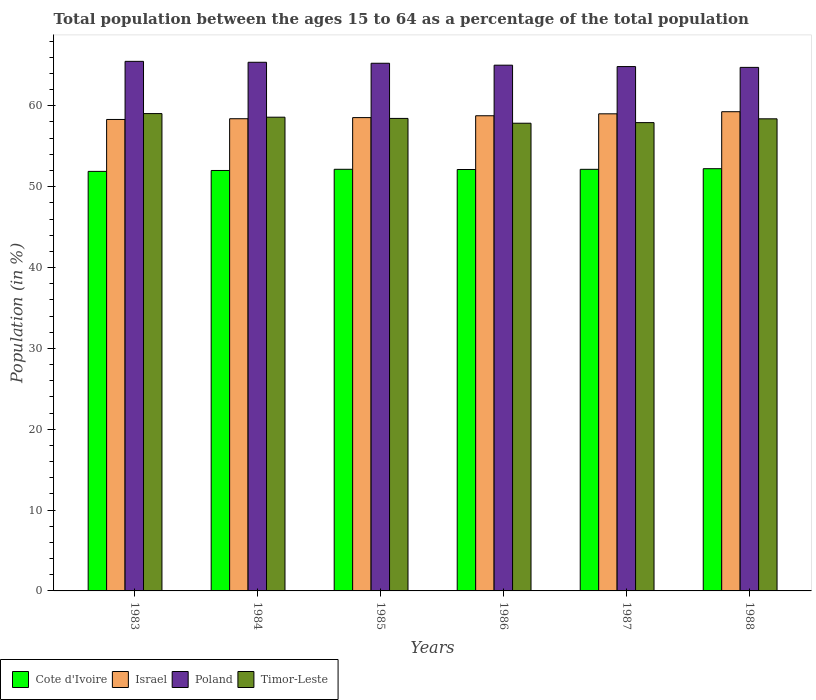Are the number of bars per tick equal to the number of legend labels?
Ensure brevity in your answer.  Yes. Are the number of bars on each tick of the X-axis equal?
Provide a short and direct response. Yes. What is the percentage of the population ages 15 to 64 in Israel in 1983?
Keep it short and to the point. 58.31. Across all years, what is the maximum percentage of the population ages 15 to 64 in Israel?
Make the answer very short. 59.27. Across all years, what is the minimum percentage of the population ages 15 to 64 in Poland?
Give a very brief answer. 64.75. What is the total percentage of the population ages 15 to 64 in Israel in the graph?
Your answer should be compact. 352.31. What is the difference between the percentage of the population ages 15 to 64 in Poland in 1985 and that in 1988?
Give a very brief answer. 0.51. What is the difference between the percentage of the population ages 15 to 64 in Poland in 1986 and the percentage of the population ages 15 to 64 in Cote d'Ivoire in 1987?
Offer a terse response. 12.88. What is the average percentage of the population ages 15 to 64 in Israel per year?
Your answer should be very brief. 58.72. In the year 1987, what is the difference between the percentage of the population ages 15 to 64 in Cote d'Ivoire and percentage of the population ages 15 to 64 in Timor-Leste?
Provide a short and direct response. -5.78. What is the ratio of the percentage of the population ages 15 to 64 in Timor-Leste in 1983 to that in 1987?
Offer a very short reply. 1.02. Is the difference between the percentage of the population ages 15 to 64 in Cote d'Ivoire in 1983 and 1986 greater than the difference between the percentage of the population ages 15 to 64 in Timor-Leste in 1983 and 1986?
Keep it short and to the point. No. What is the difference between the highest and the second highest percentage of the population ages 15 to 64 in Timor-Leste?
Offer a very short reply. 0.45. What is the difference between the highest and the lowest percentage of the population ages 15 to 64 in Timor-Leste?
Offer a terse response. 1.19. Is the sum of the percentage of the population ages 15 to 64 in Timor-Leste in 1984 and 1988 greater than the maximum percentage of the population ages 15 to 64 in Israel across all years?
Give a very brief answer. Yes. What does the 4th bar from the right in 1985 represents?
Your answer should be very brief. Cote d'Ivoire. Is it the case that in every year, the sum of the percentage of the population ages 15 to 64 in Cote d'Ivoire and percentage of the population ages 15 to 64 in Israel is greater than the percentage of the population ages 15 to 64 in Poland?
Provide a short and direct response. Yes. How many years are there in the graph?
Your answer should be very brief. 6. How many legend labels are there?
Your answer should be very brief. 4. How are the legend labels stacked?
Keep it short and to the point. Horizontal. What is the title of the graph?
Make the answer very short. Total population between the ages 15 to 64 as a percentage of the total population. Does "Uzbekistan" appear as one of the legend labels in the graph?
Offer a very short reply. No. What is the Population (in %) in Cote d'Ivoire in 1983?
Offer a terse response. 51.89. What is the Population (in %) in Israel in 1983?
Make the answer very short. 58.31. What is the Population (in %) of Poland in 1983?
Offer a terse response. 65.5. What is the Population (in %) of Timor-Leste in 1983?
Your answer should be very brief. 59.04. What is the Population (in %) in Cote d'Ivoire in 1984?
Provide a succinct answer. 52. What is the Population (in %) of Israel in 1984?
Your response must be concise. 58.4. What is the Population (in %) in Poland in 1984?
Offer a very short reply. 65.38. What is the Population (in %) in Timor-Leste in 1984?
Provide a succinct answer. 58.59. What is the Population (in %) of Cote d'Ivoire in 1985?
Your answer should be very brief. 52.15. What is the Population (in %) of Israel in 1985?
Keep it short and to the point. 58.54. What is the Population (in %) of Poland in 1985?
Keep it short and to the point. 65.26. What is the Population (in %) of Timor-Leste in 1985?
Ensure brevity in your answer.  58.44. What is the Population (in %) in Cote d'Ivoire in 1986?
Provide a short and direct response. 52.12. What is the Population (in %) of Israel in 1986?
Your response must be concise. 58.77. What is the Population (in %) in Poland in 1986?
Keep it short and to the point. 65.03. What is the Population (in %) in Timor-Leste in 1986?
Offer a terse response. 57.85. What is the Population (in %) of Cote d'Ivoire in 1987?
Make the answer very short. 52.15. What is the Population (in %) in Israel in 1987?
Provide a succinct answer. 59.01. What is the Population (in %) of Poland in 1987?
Offer a terse response. 64.85. What is the Population (in %) of Timor-Leste in 1987?
Offer a very short reply. 57.92. What is the Population (in %) in Cote d'Ivoire in 1988?
Your answer should be very brief. 52.22. What is the Population (in %) in Israel in 1988?
Offer a very short reply. 59.27. What is the Population (in %) in Poland in 1988?
Keep it short and to the point. 64.75. What is the Population (in %) in Timor-Leste in 1988?
Make the answer very short. 58.39. Across all years, what is the maximum Population (in %) of Cote d'Ivoire?
Your answer should be very brief. 52.22. Across all years, what is the maximum Population (in %) in Israel?
Ensure brevity in your answer.  59.27. Across all years, what is the maximum Population (in %) of Poland?
Make the answer very short. 65.5. Across all years, what is the maximum Population (in %) of Timor-Leste?
Make the answer very short. 59.04. Across all years, what is the minimum Population (in %) of Cote d'Ivoire?
Your answer should be very brief. 51.89. Across all years, what is the minimum Population (in %) of Israel?
Your answer should be very brief. 58.31. Across all years, what is the minimum Population (in %) in Poland?
Your answer should be very brief. 64.75. Across all years, what is the minimum Population (in %) of Timor-Leste?
Your answer should be very brief. 57.85. What is the total Population (in %) in Cote d'Ivoire in the graph?
Provide a succinct answer. 312.53. What is the total Population (in %) in Israel in the graph?
Your answer should be compact. 352.31. What is the total Population (in %) in Poland in the graph?
Your answer should be very brief. 390.78. What is the total Population (in %) of Timor-Leste in the graph?
Provide a short and direct response. 350.23. What is the difference between the Population (in %) in Cote d'Ivoire in 1983 and that in 1984?
Make the answer very short. -0.11. What is the difference between the Population (in %) of Israel in 1983 and that in 1984?
Your answer should be compact. -0.09. What is the difference between the Population (in %) of Poland in 1983 and that in 1984?
Your answer should be compact. 0.11. What is the difference between the Population (in %) in Timor-Leste in 1983 and that in 1984?
Your answer should be very brief. 0.45. What is the difference between the Population (in %) in Cote d'Ivoire in 1983 and that in 1985?
Offer a terse response. -0.26. What is the difference between the Population (in %) in Israel in 1983 and that in 1985?
Your response must be concise. -0.23. What is the difference between the Population (in %) of Poland in 1983 and that in 1985?
Offer a very short reply. 0.24. What is the difference between the Population (in %) in Timor-Leste in 1983 and that in 1985?
Offer a terse response. 0.6. What is the difference between the Population (in %) of Cote d'Ivoire in 1983 and that in 1986?
Provide a succinct answer. -0.23. What is the difference between the Population (in %) in Israel in 1983 and that in 1986?
Provide a succinct answer. -0.46. What is the difference between the Population (in %) of Poland in 1983 and that in 1986?
Make the answer very short. 0.47. What is the difference between the Population (in %) in Timor-Leste in 1983 and that in 1986?
Offer a very short reply. 1.19. What is the difference between the Population (in %) in Cote d'Ivoire in 1983 and that in 1987?
Your answer should be very brief. -0.25. What is the difference between the Population (in %) of Israel in 1983 and that in 1987?
Your answer should be very brief. -0.7. What is the difference between the Population (in %) of Poland in 1983 and that in 1987?
Make the answer very short. 0.65. What is the difference between the Population (in %) in Timor-Leste in 1983 and that in 1987?
Ensure brevity in your answer.  1.12. What is the difference between the Population (in %) of Cote d'Ivoire in 1983 and that in 1988?
Ensure brevity in your answer.  -0.33. What is the difference between the Population (in %) in Israel in 1983 and that in 1988?
Offer a very short reply. -0.96. What is the difference between the Population (in %) in Poland in 1983 and that in 1988?
Make the answer very short. 0.75. What is the difference between the Population (in %) of Timor-Leste in 1983 and that in 1988?
Your answer should be compact. 0.65. What is the difference between the Population (in %) in Cote d'Ivoire in 1984 and that in 1985?
Keep it short and to the point. -0.15. What is the difference between the Population (in %) of Israel in 1984 and that in 1985?
Offer a very short reply. -0.14. What is the difference between the Population (in %) of Poland in 1984 and that in 1985?
Provide a short and direct response. 0.12. What is the difference between the Population (in %) of Timor-Leste in 1984 and that in 1985?
Your answer should be compact. 0.15. What is the difference between the Population (in %) of Cote d'Ivoire in 1984 and that in 1986?
Keep it short and to the point. -0.12. What is the difference between the Population (in %) in Israel in 1984 and that in 1986?
Your answer should be very brief. -0.37. What is the difference between the Population (in %) of Poland in 1984 and that in 1986?
Keep it short and to the point. 0.36. What is the difference between the Population (in %) of Timor-Leste in 1984 and that in 1986?
Give a very brief answer. 0.75. What is the difference between the Population (in %) of Cote d'Ivoire in 1984 and that in 1987?
Make the answer very short. -0.14. What is the difference between the Population (in %) of Israel in 1984 and that in 1987?
Offer a terse response. -0.61. What is the difference between the Population (in %) in Poland in 1984 and that in 1987?
Keep it short and to the point. 0.53. What is the difference between the Population (in %) of Timor-Leste in 1984 and that in 1987?
Offer a very short reply. 0.67. What is the difference between the Population (in %) of Cote d'Ivoire in 1984 and that in 1988?
Your answer should be very brief. -0.22. What is the difference between the Population (in %) of Israel in 1984 and that in 1988?
Provide a short and direct response. -0.87. What is the difference between the Population (in %) of Poland in 1984 and that in 1988?
Provide a succinct answer. 0.63. What is the difference between the Population (in %) of Timor-Leste in 1984 and that in 1988?
Your answer should be very brief. 0.2. What is the difference between the Population (in %) in Cote d'Ivoire in 1985 and that in 1986?
Your answer should be compact. 0.03. What is the difference between the Population (in %) of Israel in 1985 and that in 1986?
Ensure brevity in your answer.  -0.23. What is the difference between the Population (in %) in Poland in 1985 and that in 1986?
Your answer should be very brief. 0.24. What is the difference between the Population (in %) in Timor-Leste in 1985 and that in 1986?
Make the answer very short. 0.6. What is the difference between the Population (in %) in Cote d'Ivoire in 1985 and that in 1987?
Your answer should be compact. 0. What is the difference between the Population (in %) in Israel in 1985 and that in 1987?
Ensure brevity in your answer.  -0.47. What is the difference between the Population (in %) in Poland in 1985 and that in 1987?
Make the answer very short. 0.41. What is the difference between the Population (in %) in Timor-Leste in 1985 and that in 1987?
Your response must be concise. 0.52. What is the difference between the Population (in %) in Cote d'Ivoire in 1985 and that in 1988?
Give a very brief answer. -0.07. What is the difference between the Population (in %) of Israel in 1985 and that in 1988?
Give a very brief answer. -0.73. What is the difference between the Population (in %) of Poland in 1985 and that in 1988?
Keep it short and to the point. 0.51. What is the difference between the Population (in %) in Timor-Leste in 1985 and that in 1988?
Provide a short and direct response. 0.05. What is the difference between the Population (in %) in Cote d'Ivoire in 1986 and that in 1987?
Offer a very short reply. -0.02. What is the difference between the Population (in %) in Israel in 1986 and that in 1987?
Your answer should be compact. -0.24. What is the difference between the Population (in %) in Poland in 1986 and that in 1987?
Your answer should be compact. 0.17. What is the difference between the Population (in %) of Timor-Leste in 1986 and that in 1987?
Offer a very short reply. -0.08. What is the difference between the Population (in %) in Cote d'Ivoire in 1986 and that in 1988?
Offer a terse response. -0.1. What is the difference between the Population (in %) of Israel in 1986 and that in 1988?
Provide a short and direct response. -0.5. What is the difference between the Population (in %) in Poland in 1986 and that in 1988?
Ensure brevity in your answer.  0.27. What is the difference between the Population (in %) in Timor-Leste in 1986 and that in 1988?
Keep it short and to the point. -0.55. What is the difference between the Population (in %) of Cote d'Ivoire in 1987 and that in 1988?
Provide a succinct answer. -0.08. What is the difference between the Population (in %) in Israel in 1987 and that in 1988?
Give a very brief answer. -0.26. What is the difference between the Population (in %) of Poland in 1987 and that in 1988?
Ensure brevity in your answer.  0.1. What is the difference between the Population (in %) in Timor-Leste in 1987 and that in 1988?
Your response must be concise. -0.47. What is the difference between the Population (in %) of Cote d'Ivoire in 1983 and the Population (in %) of Israel in 1984?
Offer a very short reply. -6.51. What is the difference between the Population (in %) in Cote d'Ivoire in 1983 and the Population (in %) in Poland in 1984?
Your response must be concise. -13.49. What is the difference between the Population (in %) in Cote d'Ivoire in 1983 and the Population (in %) in Timor-Leste in 1984?
Your answer should be compact. -6.7. What is the difference between the Population (in %) of Israel in 1983 and the Population (in %) of Poland in 1984?
Ensure brevity in your answer.  -7.07. What is the difference between the Population (in %) in Israel in 1983 and the Population (in %) in Timor-Leste in 1984?
Ensure brevity in your answer.  -0.28. What is the difference between the Population (in %) in Poland in 1983 and the Population (in %) in Timor-Leste in 1984?
Give a very brief answer. 6.91. What is the difference between the Population (in %) of Cote d'Ivoire in 1983 and the Population (in %) of Israel in 1985?
Make the answer very short. -6.65. What is the difference between the Population (in %) in Cote d'Ivoire in 1983 and the Population (in %) in Poland in 1985?
Offer a terse response. -13.37. What is the difference between the Population (in %) in Cote d'Ivoire in 1983 and the Population (in %) in Timor-Leste in 1985?
Offer a terse response. -6.55. What is the difference between the Population (in %) of Israel in 1983 and the Population (in %) of Poland in 1985?
Your response must be concise. -6.95. What is the difference between the Population (in %) of Israel in 1983 and the Population (in %) of Timor-Leste in 1985?
Provide a succinct answer. -0.13. What is the difference between the Population (in %) in Poland in 1983 and the Population (in %) in Timor-Leste in 1985?
Your answer should be compact. 7.06. What is the difference between the Population (in %) in Cote d'Ivoire in 1983 and the Population (in %) in Israel in 1986?
Your answer should be very brief. -6.88. What is the difference between the Population (in %) in Cote d'Ivoire in 1983 and the Population (in %) in Poland in 1986?
Ensure brevity in your answer.  -13.14. What is the difference between the Population (in %) in Cote d'Ivoire in 1983 and the Population (in %) in Timor-Leste in 1986?
Provide a short and direct response. -5.96. What is the difference between the Population (in %) in Israel in 1983 and the Population (in %) in Poland in 1986?
Your answer should be very brief. -6.71. What is the difference between the Population (in %) in Israel in 1983 and the Population (in %) in Timor-Leste in 1986?
Give a very brief answer. 0.47. What is the difference between the Population (in %) in Poland in 1983 and the Population (in %) in Timor-Leste in 1986?
Keep it short and to the point. 7.65. What is the difference between the Population (in %) in Cote d'Ivoire in 1983 and the Population (in %) in Israel in 1987?
Your response must be concise. -7.12. What is the difference between the Population (in %) of Cote d'Ivoire in 1983 and the Population (in %) of Poland in 1987?
Keep it short and to the point. -12.96. What is the difference between the Population (in %) in Cote d'Ivoire in 1983 and the Population (in %) in Timor-Leste in 1987?
Give a very brief answer. -6.03. What is the difference between the Population (in %) in Israel in 1983 and the Population (in %) in Poland in 1987?
Provide a succinct answer. -6.54. What is the difference between the Population (in %) of Israel in 1983 and the Population (in %) of Timor-Leste in 1987?
Offer a terse response. 0.39. What is the difference between the Population (in %) of Poland in 1983 and the Population (in %) of Timor-Leste in 1987?
Provide a succinct answer. 7.58. What is the difference between the Population (in %) of Cote d'Ivoire in 1983 and the Population (in %) of Israel in 1988?
Your answer should be compact. -7.38. What is the difference between the Population (in %) in Cote d'Ivoire in 1983 and the Population (in %) in Poland in 1988?
Provide a succinct answer. -12.86. What is the difference between the Population (in %) of Cote d'Ivoire in 1983 and the Population (in %) of Timor-Leste in 1988?
Keep it short and to the point. -6.5. What is the difference between the Population (in %) in Israel in 1983 and the Population (in %) in Poland in 1988?
Keep it short and to the point. -6.44. What is the difference between the Population (in %) of Israel in 1983 and the Population (in %) of Timor-Leste in 1988?
Offer a very short reply. -0.08. What is the difference between the Population (in %) of Poland in 1983 and the Population (in %) of Timor-Leste in 1988?
Make the answer very short. 7.11. What is the difference between the Population (in %) in Cote d'Ivoire in 1984 and the Population (in %) in Israel in 1985?
Give a very brief answer. -6.54. What is the difference between the Population (in %) of Cote d'Ivoire in 1984 and the Population (in %) of Poland in 1985?
Keep it short and to the point. -13.26. What is the difference between the Population (in %) of Cote d'Ivoire in 1984 and the Population (in %) of Timor-Leste in 1985?
Your response must be concise. -6.44. What is the difference between the Population (in %) of Israel in 1984 and the Population (in %) of Poland in 1985?
Offer a terse response. -6.86. What is the difference between the Population (in %) in Israel in 1984 and the Population (in %) in Timor-Leste in 1985?
Give a very brief answer. -0.04. What is the difference between the Population (in %) of Poland in 1984 and the Population (in %) of Timor-Leste in 1985?
Ensure brevity in your answer.  6.94. What is the difference between the Population (in %) in Cote d'Ivoire in 1984 and the Population (in %) in Israel in 1986?
Offer a very short reply. -6.77. What is the difference between the Population (in %) of Cote d'Ivoire in 1984 and the Population (in %) of Poland in 1986?
Offer a very short reply. -13.02. What is the difference between the Population (in %) of Cote d'Ivoire in 1984 and the Population (in %) of Timor-Leste in 1986?
Give a very brief answer. -5.84. What is the difference between the Population (in %) of Israel in 1984 and the Population (in %) of Poland in 1986?
Ensure brevity in your answer.  -6.62. What is the difference between the Population (in %) of Israel in 1984 and the Population (in %) of Timor-Leste in 1986?
Offer a very short reply. 0.56. What is the difference between the Population (in %) of Poland in 1984 and the Population (in %) of Timor-Leste in 1986?
Keep it short and to the point. 7.54. What is the difference between the Population (in %) of Cote d'Ivoire in 1984 and the Population (in %) of Israel in 1987?
Keep it short and to the point. -7.01. What is the difference between the Population (in %) of Cote d'Ivoire in 1984 and the Population (in %) of Poland in 1987?
Provide a succinct answer. -12.85. What is the difference between the Population (in %) in Cote d'Ivoire in 1984 and the Population (in %) in Timor-Leste in 1987?
Give a very brief answer. -5.92. What is the difference between the Population (in %) of Israel in 1984 and the Population (in %) of Poland in 1987?
Keep it short and to the point. -6.45. What is the difference between the Population (in %) in Israel in 1984 and the Population (in %) in Timor-Leste in 1987?
Offer a very short reply. 0.48. What is the difference between the Population (in %) in Poland in 1984 and the Population (in %) in Timor-Leste in 1987?
Your answer should be compact. 7.46. What is the difference between the Population (in %) in Cote d'Ivoire in 1984 and the Population (in %) in Israel in 1988?
Offer a very short reply. -7.27. What is the difference between the Population (in %) of Cote d'Ivoire in 1984 and the Population (in %) of Poland in 1988?
Your response must be concise. -12.75. What is the difference between the Population (in %) in Cote d'Ivoire in 1984 and the Population (in %) in Timor-Leste in 1988?
Your answer should be very brief. -6.39. What is the difference between the Population (in %) in Israel in 1984 and the Population (in %) in Poland in 1988?
Offer a very short reply. -6.35. What is the difference between the Population (in %) of Israel in 1984 and the Population (in %) of Timor-Leste in 1988?
Provide a short and direct response. 0.01. What is the difference between the Population (in %) in Poland in 1984 and the Population (in %) in Timor-Leste in 1988?
Your answer should be very brief. 6.99. What is the difference between the Population (in %) of Cote d'Ivoire in 1985 and the Population (in %) of Israel in 1986?
Provide a succinct answer. -6.62. What is the difference between the Population (in %) in Cote d'Ivoire in 1985 and the Population (in %) in Poland in 1986?
Provide a succinct answer. -12.88. What is the difference between the Population (in %) of Cote d'Ivoire in 1985 and the Population (in %) of Timor-Leste in 1986?
Keep it short and to the point. -5.7. What is the difference between the Population (in %) of Israel in 1985 and the Population (in %) of Poland in 1986?
Your answer should be very brief. -6.49. What is the difference between the Population (in %) of Israel in 1985 and the Population (in %) of Timor-Leste in 1986?
Offer a very short reply. 0.69. What is the difference between the Population (in %) in Poland in 1985 and the Population (in %) in Timor-Leste in 1986?
Ensure brevity in your answer.  7.42. What is the difference between the Population (in %) of Cote d'Ivoire in 1985 and the Population (in %) of Israel in 1987?
Keep it short and to the point. -6.86. What is the difference between the Population (in %) of Cote d'Ivoire in 1985 and the Population (in %) of Poland in 1987?
Keep it short and to the point. -12.7. What is the difference between the Population (in %) in Cote d'Ivoire in 1985 and the Population (in %) in Timor-Leste in 1987?
Your answer should be compact. -5.77. What is the difference between the Population (in %) in Israel in 1985 and the Population (in %) in Poland in 1987?
Offer a very short reply. -6.31. What is the difference between the Population (in %) of Israel in 1985 and the Population (in %) of Timor-Leste in 1987?
Keep it short and to the point. 0.62. What is the difference between the Population (in %) of Poland in 1985 and the Population (in %) of Timor-Leste in 1987?
Give a very brief answer. 7.34. What is the difference between the Population (in %) of Cote d'Ivoire in 1985 and the Population (in %) of Israel in 1988?
Your answer should be compact. -7.12. What is the difference between the Population (in %) in Cote d'Ivoire in 1985 and the Population (in %) in Poland in 1988?
Provide a short and direct response. -12.6. What is the difference between the Population (in %) of Cote d'Ivoire in 1985 and the Population (in %) of Timor-Leste in 1988?
Provide a short and direct response. -6.24. What is the difference between the Population (in %) in Israel in 1985 and the Population (in %) in Poland in 1988?
Your answer should be compact. -6.21. What is the difference between the Population (in %) of Israel in 1985 and the Population (in %) of Timor-Leste in 1988?
Ensure brevity in your answer.  0.15. What is the difference between the Population (in %) in Poland in 1985 and the Population (in %) in Timor-Leste in 1988?
Give a very brief answer. 6.87. What is the difference between the Population (in %) of Cote d'Ivoire in 1986 and the Population (in %) of Israel in 1987?
Give a very brief answer. -6.89. What is the difference between the Population (in %) in Cote d'Ivoire in 1986 and the Population (in %) in Poland in 1987?
Ensure brevity in your answer.  -12.73. What is the difference between the Population (in %) of Cote d'Ivoire in 1986 and the Population (in %) of Timor-Leste in 1987?
Offer a very short reply. -5.8. What is the difference between the Population (in %) in Israel in 1986 and the Population (in %) in Poland in 1987?
Offer a terse response. -6.08. What is the difference between the Population (in %) in Israel in 1986 and the Population (in %) in Timor-Leste in 1987?
Offer a very short reply. 0.85. What is the difference between the Population (in %) in Poland in 1986 and the Population (in %) in Timor-Leste in 1987?
Provide a succinct answer. 7.1. What is the difference between the Population (in %) of Cote d'Ivoire in 1986 and the Population (in %) of Israel in 1988?
Offer a very short reply. -7.15. What is the difference between the Population (in %) in Cote d'Ivoire in 1986 and the Population (in %) in Poland in 1988?
Your answer should be very brief. -12.63. What is the difference between the Population (in %) in Cote d'Ivoire in 1986 and the Population (in %) in Timor-Leste in 1988?
Provide a short and direct response. -6.27. What is the difference between the Population (in %) in Israel in 1986 and the Population (in %) in Poland in 1988?
Your answer should be very brief. -5.98. What is the difference between the Population (in %) in Israel in 1986 and the Population (in %) in Timor-Leste in 1988?
Provide a short and direct response. 0.38. What is the difference between the Population (in %) of Poland in 1986 and the Population (in %) of Timor-Leste in 1988?
Provide a succinct answer. 6.63. What is the difference between the Population (in %) of Cote d'Ivoire in 1987 and the Population (in %) of Israel in 1988?
Your answer should be compact. -7.13. What is the difference between the Population (in %) in Cote d'Ivoire in 1987 and the Population (in %) in Poland in 1988?
Ensure brevity in your answer.  -12.61. What is the difference between the Population (in %) in Cote d'Ivoire in 1987 and the Population (in %) in Timor-Leste in 1988?
Offer a very short reply. -6.25. What is the difference between the Population (in %) of Israel in 1987 and the Population (in %) of Poland in 1988?
Offer a very short reply. -5.74. What is the difference between the Population (in %) in Israel in 1987 and the Population (in %) in Timor-Leste in 1988?
Offer a very short reply. 0.62. What is the difference between the Population (in %) of Poland in 1987 and the Population (in %) of Timor-Leste in 1988?
Offer a terse response. 6.46. What is the average Population (in %) in Cote d'Ivoire per year?
Provide a succinct answer. 52.09. What is the average Population (in %) in Israel per year?
Your response must be concise. 58.72. What is the average Population (in %) in Poland per year?
Your response must be concise. 65.13. What is the average Population (in %) of Timor-Leste per year?
Provide a succinct answer. 58.37. In the year 1983, what is the difference between the Population (in %) in Cote d'Ivoire and Population (in %) in Israel?
Make the answer very short. -6.42. In the year 1983, what is the difference between the Population (in %) in Cote d'Ivoire and Population (in %) in Poland?
Offer a terse response. -13.61. In the year 1983, what is the difference between the Population (in %) of Cote d'Ivoire and Population (in %) of Timor-Leste?
Keep it short and to the point. -7.15. In the year 1983, what is the difference between the Population (in %) of Israel and Population (in %) of Poland?
Keep it short and to the point. -7.19. In the year 1983, what is the difference between the Population (in %) of Israel and Population (in %) of Timor-Leste?
Ensure brevity in your answer.  -0.73. In the year 1983, what is the difference between the Population (in %) of Poland and Population (in %) of Timor-Leste?
Give a very brief answer. 6.46. In the year 1984, what is the difference between the Population (in %) in Cote d'Ivoire and Population (in %) in Israel?
Give a very brief answer. -6.4. In the year 1984, what is the difference between the Population (in %) of Cote d'Ivoire and Population (in %) of Poland?
Your answer should be compact. -13.38. In the year 1984, what is the difference between the Population (in %) of Cote d'Ivoire and Population (in %) of Timor-Leste?
Offer a terse response. -6.59. In the year 1984, what is the difference between the Population (in %) of Israel and Population (in %) of Poland?
Provide a short and direct response. -6.98. In the year 1984, what is the difference between the Population (in %) in Israel and Population (in %) in Timor-Leste?
Make the answer very short. -0.19. In the year 1984, what is the difference between the Population (in %) in Poland and Population (in %) in Timor-Leste?
Keep it short and to the point. 6.79. In the year 1985, what is the difference between the Population (in %) in Cote d'Ivoire and Population (in %) in Israel?
Provide a succinct answer. -6.39. In the year 1985, what is the difference between the Population (in %) in Cote d'Ivoire and Population (in %) in Poland?
Provide a short and direct response. -13.11. In the year 1985, what is the difference between the Population (in %) of Cote d'Ivoire and Population (in %) of Timor-Leste?
Your response must be concise. -6.29. In the year 1985, what is the difference between the Population (in %) in Israel and Population (in %) in Poland?
Your answer should be compact. -6.72. In the year 1985, what is the difference between the Population (in %) in Israel and Population (in %) in Timor-Leste?
Provide a short and direct response. 0.1. In the year 1985, what is the difference between the Population (in %) in Poland and Population (in %) in Timor-Leste?
Your answer should be compact. 6.82. In the year 1986, what is the difference between the Population (in %) of Cote d'Ivoire and Population (in %) of Israel?
Offer a very short reply. -6.65. In the year 1986, what is the difference between the Population (in %) of Cote d'Ivoire and Population (in %) of Poland?
Your response must be concise. -12.9. In the year 1986, what is the difference between the Population (in %) in Cote d'Ivoire and Population (in %) in Timor-Leste?
Provide a short and direct response. -5.72. In the year 1986, what is the difference between the Population (in %) of Israel and Population (in %) of Poland?
Your response must be concise. -6.26. In the year 1986, what is the difference between the Population (in %) in Israel and Population (in %) in Timor-Leste?
Make the answer very short. 0.92. In the year 1986, what is the difference between the Population (in %) of Poland and Population (in %) of Timor-Leste?
Give a very brief answer. 7.18. In the year 1987, what is the difference between the Population (in %) of Cote d'Ivoire and Population (in %) of Israel?
Your response must be concise. -6.87. In the year 1987, what is the difference between the Population (in %) of Cote d'Ivoire and Population (in %) of Poland?
Provide a short and direct response. -12.71. In the year 1987, what is the difference between the Population (in %) of Cote d'Ivoire and Population (in %) of Timor-Leste?
Give a very brief answer. -5.78. In the year 1987, what is the difference between the Population (in %) in Israel and Population (in %) in Poland?
Offer a terse response. -5.84. In the year 1987, what is the difference between the Population (in %) in Israel and Population (in %) in Timor-Leste?
Give a very brief answer. 1.09. In the year 1987, what is the difference between the Population (in %) of Poland and Population (in %) of Timor-Leste?
Offer a terse response. 6.93. In the year 1988, what is the difference between the Population (in %) of Cote d'Ivoire and Population (in %) of Israel?
Your answer should be very brief. -7.05. In the year 1988, what is the difference between the Population (in %) in Cote d'Ivoire and Population (in %) in Poland?
Offer a very short reply. -12.53. In the year 1988, what is the difference between the Population (in %) of Cote d'Ivoire and Population (in %) of Timor-Leste?
Your response must be concise. -6.17. In the year 1988, what is the difference between the Population (in %) of Israel and Population (in %) of Poland?
Offer a very short reply. -5.48. In the year 1988, what is the difference between the Population (in %) of Israel and Population (in %) of Timor-Leste?
Provide a succinct answer. 0.88. In the year 1988, what is the difference between the Population (in %) of Poland and Population (in %) of Timor-Leste?
Your response must be concise. 6.36. What is the ratio of the Population (in %) in Israel in 1983 to that in 1984?
Keep it short and to the point. 1. What is the ratio of the Population (in %) in Timor-Leste in 1983 to that in 1984?
Offer a very short reply. 1.01. What is the ratio of the Population (in %) of Timor-Leste in 1983 to that in 1985?
Provide a short and direct response. 1.01. What is the ratio of the Population (in %) of Poland in 1983 to that in 1986?
Your answer should be very brief. 1.01. What is the ratio of the Population (in %) in Timor-Leste in 1983 to that in 1986?
Your answer should be compact. 1.02. What is the ratio of the Population (in %) in Cote d'Ivoire in 1983 to that in 1987?
Your response must be concise. 1. What is the ratio of the Population (in %) in Poland in 1983 to that in 1987?
Your answer should be compact. 1.01. What is the ratio of the Population (in %) of Timor-Leste in 1983 to that in 1987?
Your answer should be very brief. 1.02. What is the ratio of the Population (in %) of Israel in 1983 to that in 1988?
Offer a terse response. 0.98. What is the ratio of the Population (in %) in Poland in 1983 to that in 1988?
Make the answer very short. 1.01. What is the ratio of the Population (in %) of Timor-Leste in 1983 to that in 1988?
Your answer should be compact. 1.01. What is the ratio of the Population (in %) of Cote d'Ivoire in 1984 to that in 1985?
Provide a succinct answer. 1. What is the ratio of the Population (in %) of Cote d'Ivoire in 1984 to that in 1986?
Ensure brevity in your answer.  1. What is the ratio of the Population (in %) in Israel in 1984 to that in 1986?
Provide a succinct answer. 0.99. What is the ratio of the Population (in %) of Poland in 1984 to that in 1986?
Give a very brief answer. 1.01. What is the ratio of the Population (in %) in Timor-Leste in 1984 to that in 1986?
Your response must be concise. 1.01. What is the ratio of the Population (in %) of Cote d'Ivoire in 1984 to that in 1987?
Your response must be concise. 1. What is the ratio of the Population (in %) in Poland in 1984 to that in 1987?
Offer a terse response. 1.01. What is the ratio of the Population (in %) in Timor-Leste in 1984 to that in 1987?
Keep it short and to the point. 1.01. What is the ratio of the Population (in %) in Israel in 1984 to that in 1988?
Give a very brief answer. 0.99. What is the ratio of the Population (in %) of Poland in 1984 to that in 1988?
Keep it short and to the point. 1.01. What is the ratio of the Population (in %) in Timor-Leste in 1984 to that in 1988?
Your response must be concise. 1. What is the ratio of the Population (in %) in Cote d'Ivoire in 1985 to that in 1986?
Offer a very short reply. 1. What is the ratio of the Population (in %) of Poland in 1985 to that in 1986?
Ensure brevity in your answer.  1. What is the ratio of the Population (in %) in Timor-Leste in 1985 to that in 1986?
Ensure brevity in your answer.  1.01. What is the ratio of the Population (in %) of Israel in 1985 to that in 1987?
Provide a succinct answer. 0.99. What is the ratio of the Population (in %) in Poland in 1985 to that in 1988?
Provide a succinct answer. 1.01. What is the ratio of the Population (in %) of Timor-Leste in 1985 to that in 1988?
Provide a short and direct response. 1. What is the ratio of the Population (in %) in Timor-Leste in 1986 to that in 1988?
Your response must be concise. 0.99. What is the ratio of the Population (in %) of Israel in 1987 to that in 1988?
Your response must be concise. 1. What is the ratio of the Population (in %) in Poland in 1987 to that in 1988?
Offer a terse response. 1. What is the ratio of the Population (in %) in Timor-Leste in 1987 to that in 1988?
Offer a very short reply. 0.99. What is the difference between the highest and the second highest Population (in %) of Cote d'Ivoire?
Your response must be concise. 0.07. What is the difference between the highest and the second highest Population (in %) of Israel?
Provide a short and direct response. 0.26. What is the difference between the highest and the second highest Population (in %) of Poland?
Your response must be concise. 0.11. What is the difference between the highest and the second highest Population (in %) of Timor-Leste?
Ensure brevity in your answer.  0.45. What is the difference between the highest and the lowest Population (in %) of Cote d'Ivoire?
Your response must be concise. 0.33. What is the difference between the highest and the lowest Population (in %) in Israel?
Your response must be concise. 0.96. What is the difference between the highest and the lowest Population (in %) of Poland?
Give a very brief answer. 0.75. What is the difference between the highest and the lowest Population (in %) of Timor-Leste?
Your answer should be compact. 1.19. 